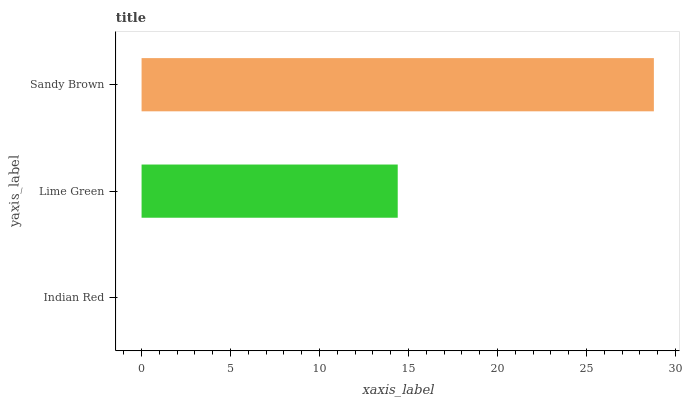Is Indian Red the minimum?
Answer yes or no. Yes. Is Sandy Brown the maximum?
Answer yes or no. Yes. Is Lime Green the minimum?
Answer yes or no. No. Is Lime Green the maximum?
Answer yes or no. No. Is Lime Green greater than Indian Red?
Answer yes or no. Yes. Is Indian Red less than Lime Green?
Answer yes or no. Yes. Is Indian Red greater than Lime Green?
Answer yes or no. No. Is Lime Green less than Indian Red?
Answer yes or no. No. Is Lime Green the high median?
Answer yes or no. Yes. Is Lime Green the low median?
Answer yes or no. Yes. Is Sandy Brown the high median?
Answer yes or no. No. Is Sandy Brown the low median?
Answer yes or no. No. 